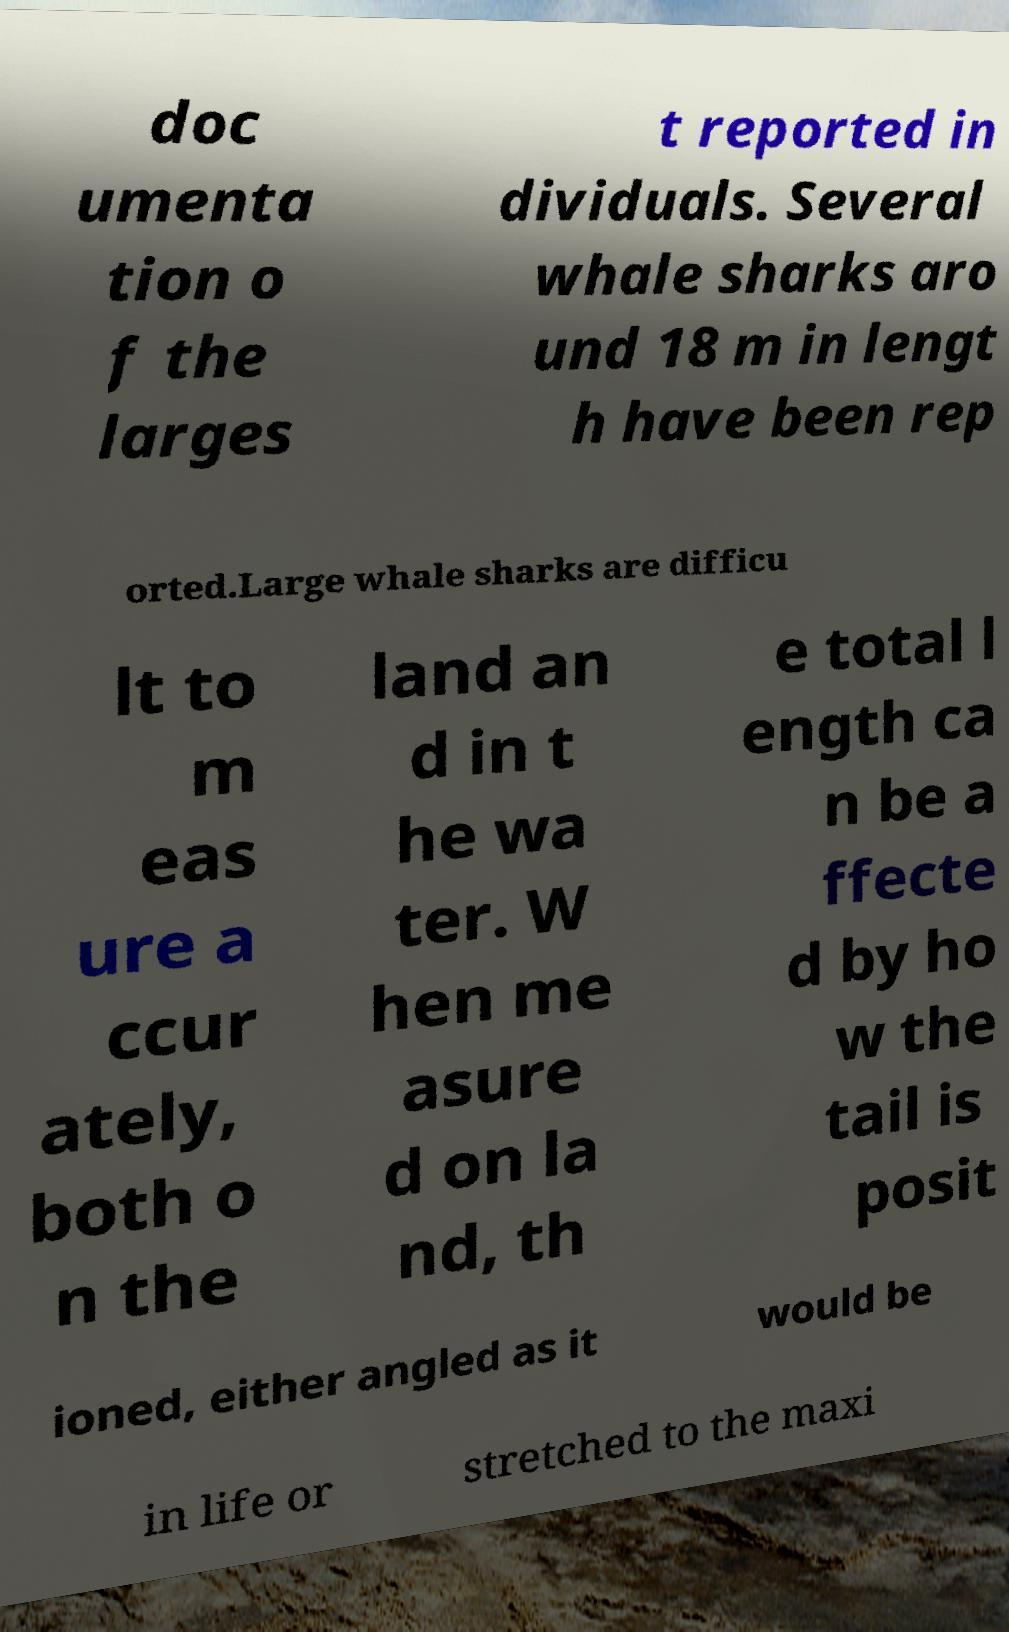Please read and relay the text visible in this image. What does it say? doc umenta tion o f the larges t reported in dividuals. Several whale sharks aro und 18 m in lengt h have been rep orted.Large whale sharks are difficu lt to m eas ure a ccur ately, both o n the land an d in t he wa ter. W hen me asure d on la nd, th e total l ength ca n be a ffecte d by ho w the tail is posit ioned, either angled as it would be in life or stretched to the maxi 